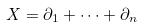Convert formula to latex. <formula><loc_0><loc_0><loc_500><loc_500>X = \partial _ { 1 } + \cdots + \partial _ { n }</formula> 